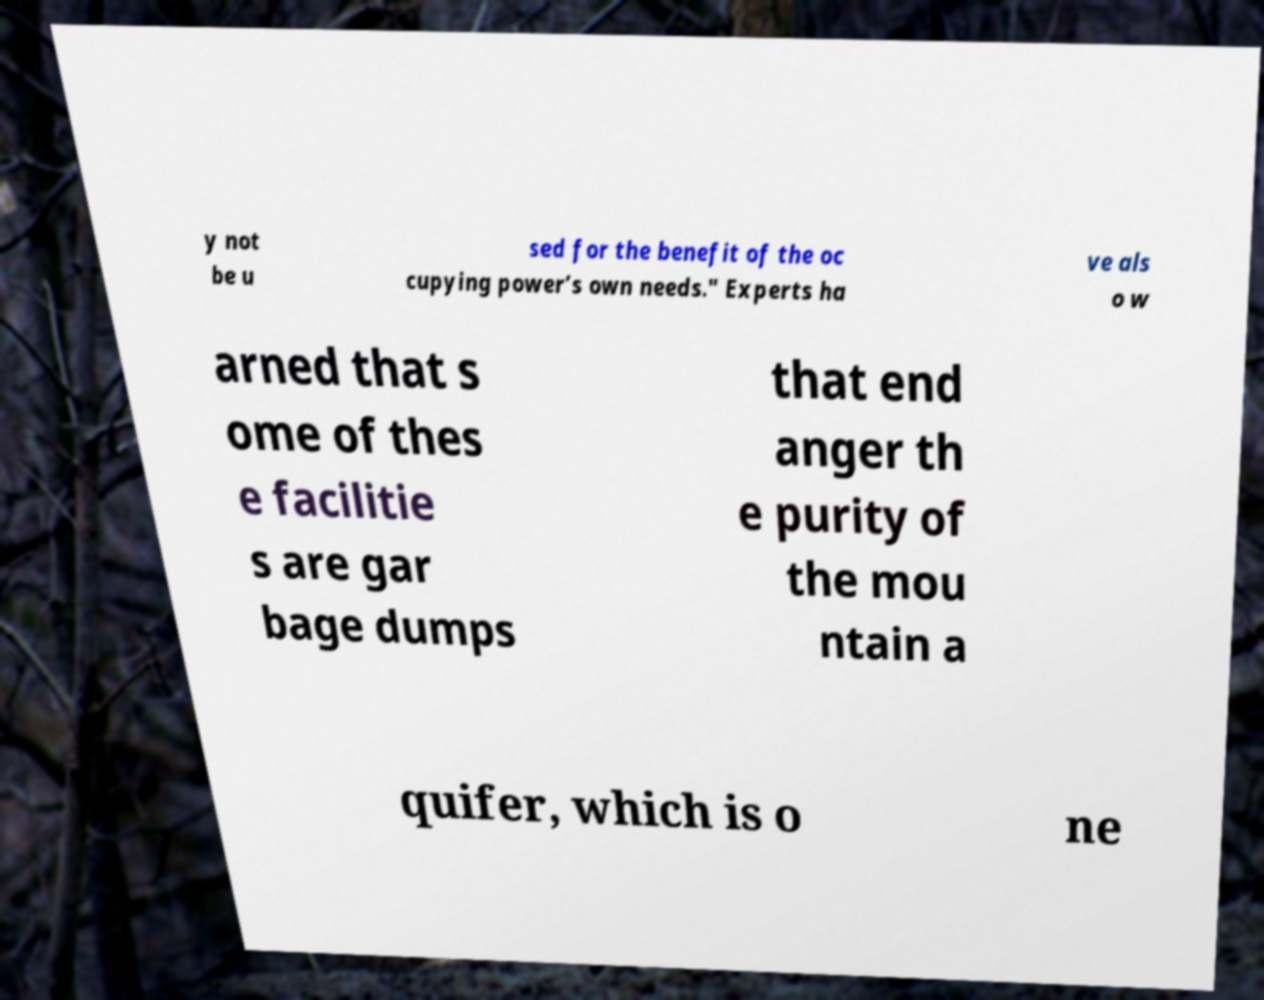Please identify and transcribe the text found in this image. y not be u sed for the benefit of the oc cupying power’s own needs." Experts ha ve als o w arned that s ome of thes e facilitie s are gar bage dumps that end anger th e purity of the mou ntain a quifer, which is o ne 